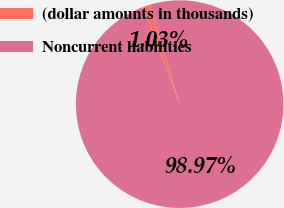Convert chart. <chart><loc_0><loc_0><loc_500><loc_500><pie_chart><fcel>(dollar amounts in thousands)<fcel>Noncurrent liabilities<nl><fcel>1.03%<fcel>98.97%<nl></chart> 